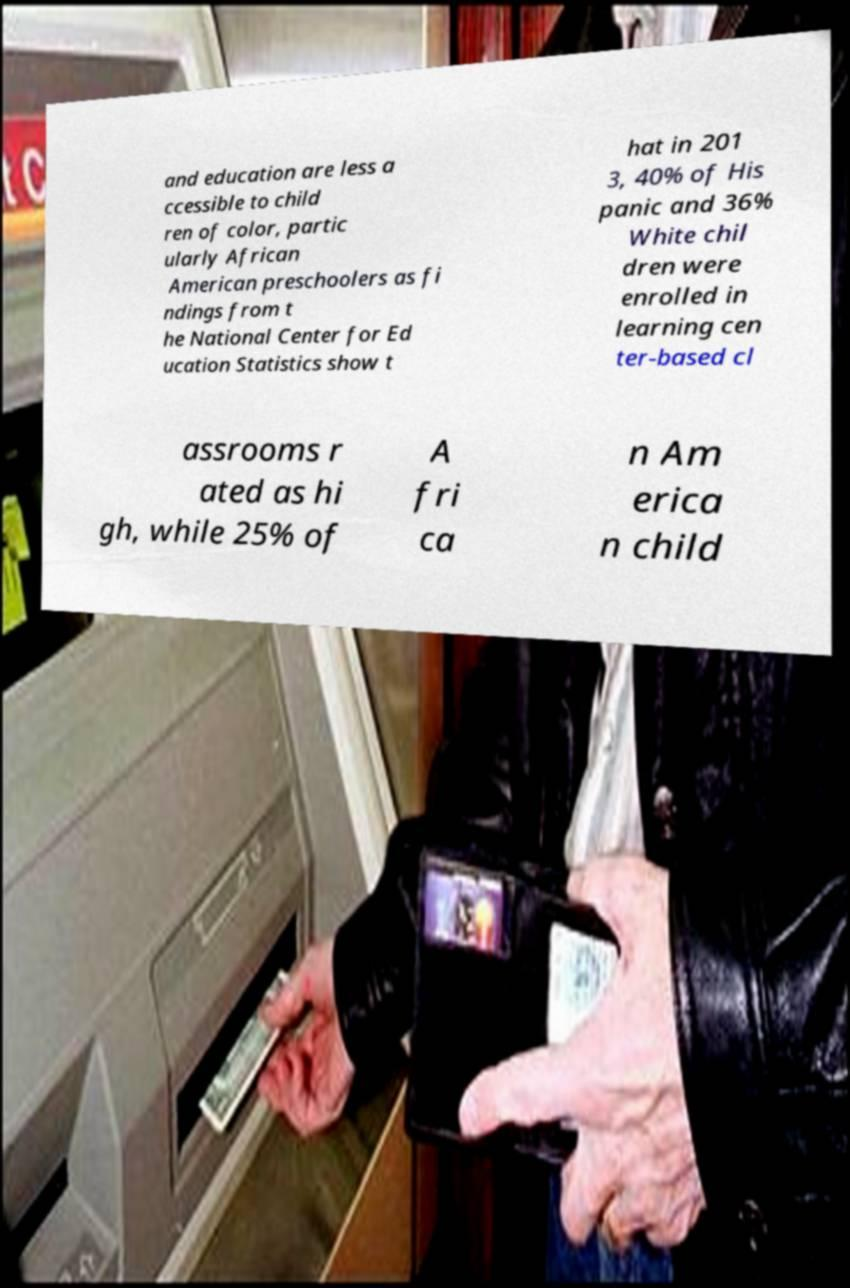Could you extract and type out the text from this image? and education are less a ccessible to child ren of color, partic ularly African American preschoolers as fi ndings from t he National Center for Ed ucation Statistics show t hat in 201 3, 40% of His panic and 36% White chil dren were enrolled in learning cen ter-based cl assrooms r ated as hi gh, while 25% of A fri ca n Am erica n child 